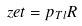Convert formula to latex. <formula><loc_0><loc_0><loc_500><loc_500>\ z e t = p _ { T l } R</formula> 